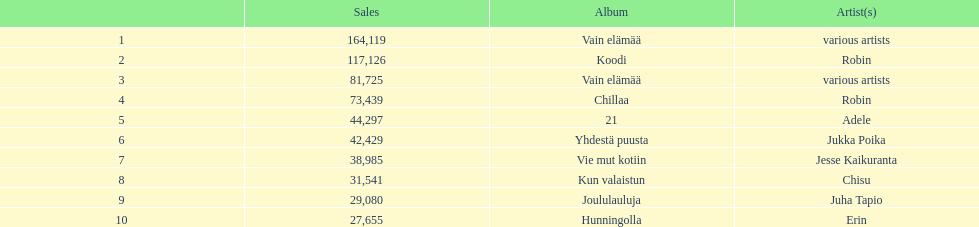What was the top selling album in this year? Vain elämää. 